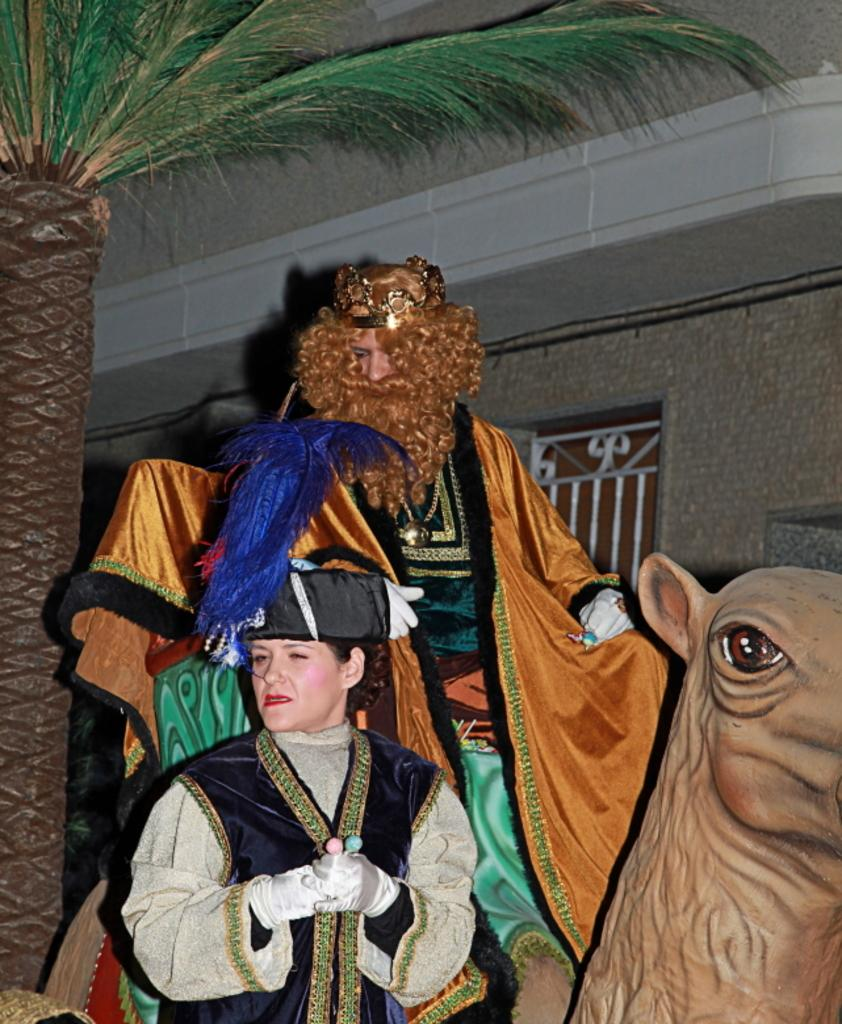How many people are in the front portion of the image? There are two people in the front portion of the image. What is located in the front portion of the image along with the people? There is a statue and a tree in the front portion of the image. What is the statue being used for in the image? A person is sitting on the statue. What can be seen in the background of the image? There is a building and a window in the background of the image. How many snails are crawling on the tree in the image? There are no snails visible in the image; only the statue, tree, and people are present. What type of oranges can be seen hanging from the window in the background? There are no oranges present in the image; only the building and window are visible in the background. 